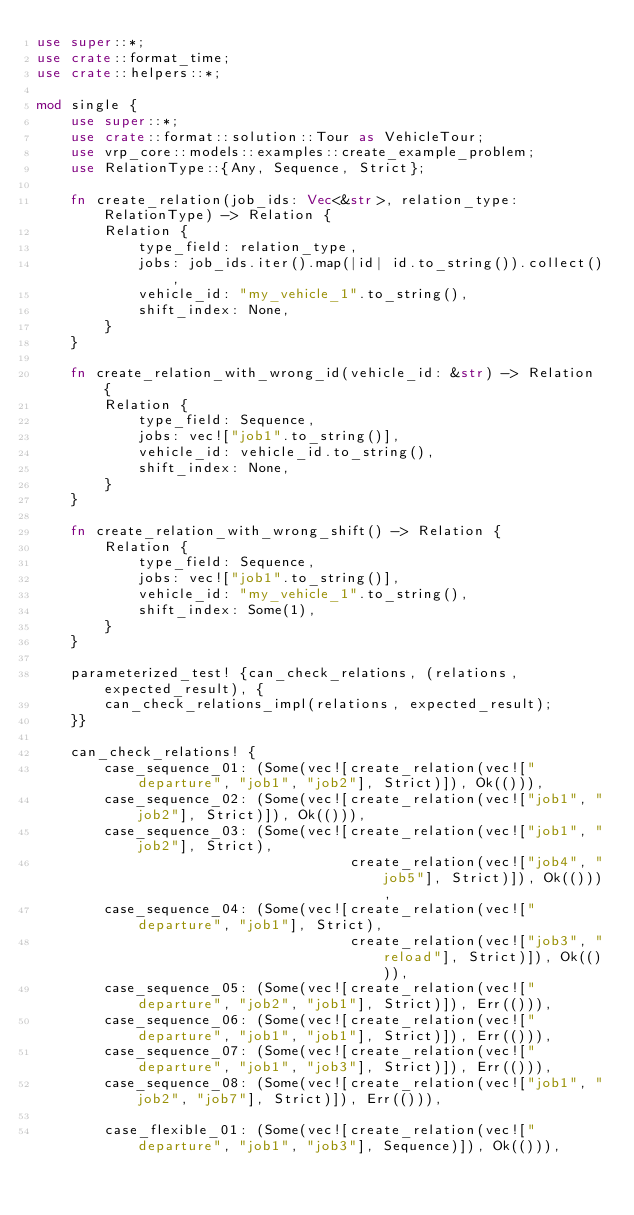<code> <loc_0><loc_0><loc_500><loc_500><_Rust_>use super::*;
use crate::format_time;
use crate::helpers::*;

mod single {
    use super::*;
    use crate::format::solution::Tour as VehicleTour;
    use vrp_core::models::examples::create_example_problem;
    use RelationType::{Any, Sequence, Strict};

    fn create_relation(job_ids: Vec<&str>, relation_type: RelationType) -> Relation {
        Relation {
            type_field: relation_type,
            jobs: job_ids.iter().map(|id| id.to_string()).collect(),
            vehicle_id: "my_vehicle_1".to_string(),
            shift_index: None,
        }
    }

    fn create_relation_with_wrong_id(vehicle_id: &str) -> Relation {
        Relation {
            type_field: Sequence,
            jobs: vec!["job1".to_string()],
            vehicle_id: vehicle_id.to_string(),
            shift_index: None,
        }
    }

    fn create_relation_with_wrong_shift() -> Relation {
        Relation {
            type_field: Sequence,
            jobs: vec!["job1".to_string()],
            vehicle_id: "my_vehicle_1".to_string(),
            shift_index: Some(1),
        }
    }

    parameterized_test! {can_check_relations, (relations, expected_result), {
        can_check_relations_impl(relations, expected_result);
    }}

    can_check_relations! {
        case_sequence_01: (Some(vec![create_relation(vec!["departure", "job1", "job2"], Strict)]), Ok(())),
        case_sequence_02: (Some(vec![create_relation(vec!["job1", "job2"], Strict)]), Ok(())),
        case_sequence_03: (Some(vec![create_relation(vec!["job1", "job2"], Strict),
                                     create_relation(vec!["job4", "job5"], Strict)]), Ok(())),
        case_sequence_04: (Some(vec![create_relation(vec!["departure", "job1"], Strict),
                                     create_relation(vec!["job3", "reload"], Strict)]), Ok(())),
        case_sequence_05: (Some(vec![create_relation(vec!["departure", "job2", "job1"], Strict)]), Err(())),
        case_sequence_06: (Some(vec![create_relation(vec!["departure", "job1", "job1"], Strict)]), Err(())),
        case_sequence_07: (Some(vec![create_relation(vec!["departure", "job1", "job3"], Strict)]), Err(())),
        case_sequence_08: (Some(vec![create_relation(vec!["job1", "job2", "job7"], Strict)]), Err(())),

        case_flexible_01: (Some(vec![create_relation(vec!["departure", "job1", "job3"], Sequence)]), Ok(())),</code> 